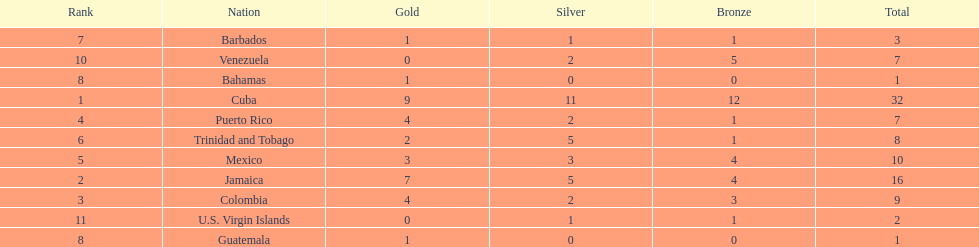Which 3 countries were awarded the most medals? Cuba, Jamaica, Colombia. Of these 3 countries which ones are islands? Cuba, Jamaica. Which one won the most silver medals? Cuba. 